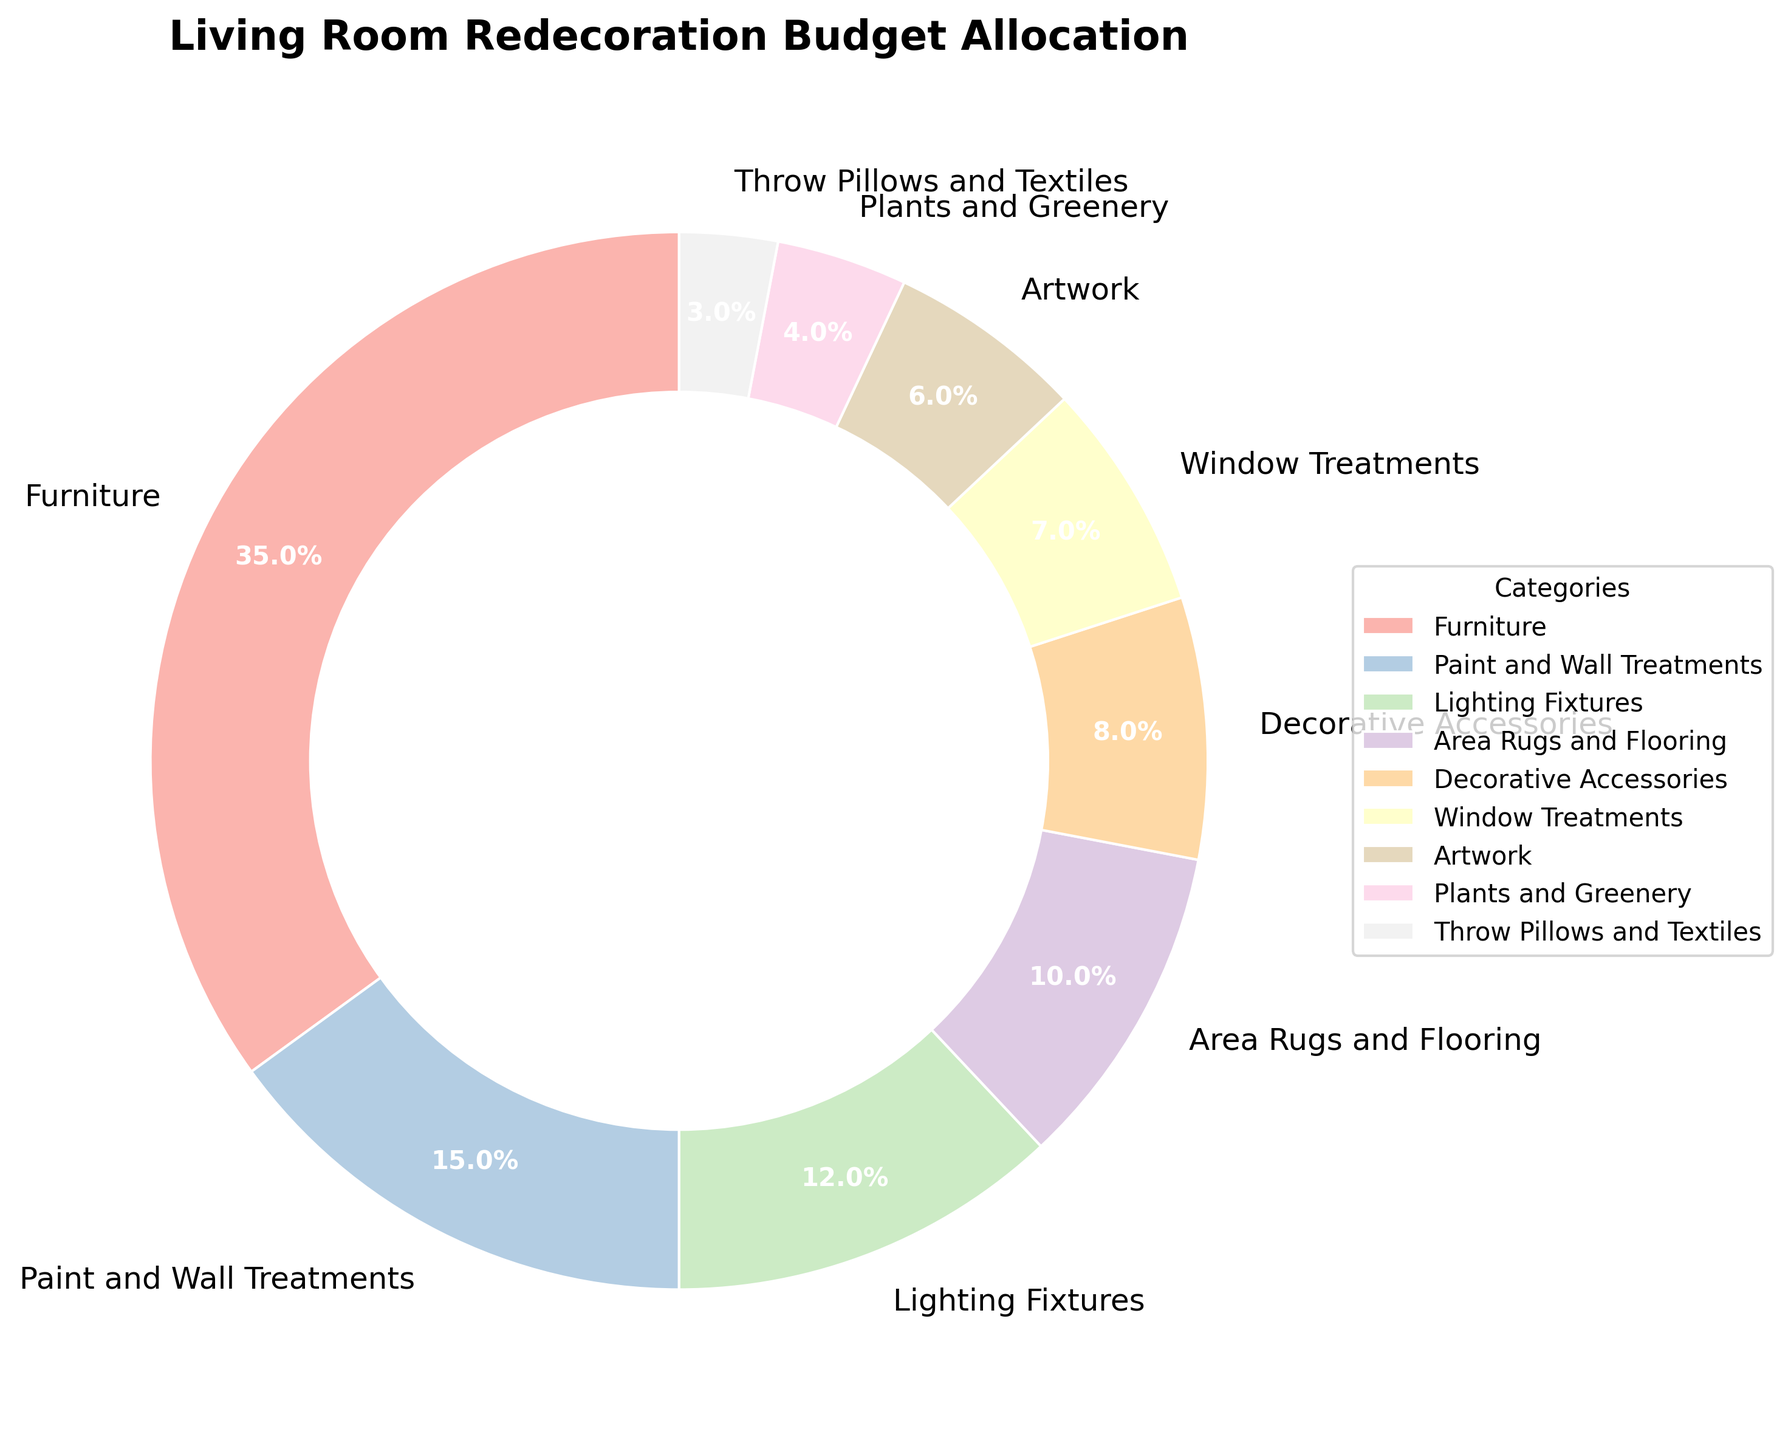What's the largest budget category? By looking at the pie chart, the largest segment corresponds to "Furniture" with a percentage of 35%.
Answer: Furniture Which category has the smallest budget allocation? The smallest segment in the pie chart is for "Throw Pillows and Textiles," which has a 3% allocation.
Answer: Throw Pillows and Textiles What is the combined percentage for Paint and Wall Treatments and Lighting Fixtures? The percentage for Paint and Wall Treatments is 15%, and for Lighting Fixtures, it is 12%. Adding these together: 15% + 12% = 27%.
Answer: 27% Is the budget allocated to Plants and Greenery greater than the budget for Throw Pillows and Textiles? The percentage for Plants and Greenery is 4%, while that for Throw Pillows and Textiles is 3%. Since 4% is greater than 3%, the budget for Plants and Greenery is indeed greater.
Answer: Yes What's the difference in budget percentage between Decorative Accessories and Artwork? Decorative Accessories have an 8% budget allocation, while Artwork has 6%. The difference is calculated as: 8% - 6% = 2%.
Answer: 2% What's the sum of the percentages for Window Treatments, Artwork, and Plants and Greenery? The budget allocations for Window Treatments, Artwork, and Plants and Greenery are 7%, 6%, and 4% respectively. Adding these together: 7% + 6% + 4% = 17%.
Answer: 17% How does the budget for Area Rugs and Flooring compare to the budget for Lighting Fixtures? The pie chart shows that both categories have relatively similar sizes. The allocation for Lighting Fixtures is 12%, and for Area Rugs and Flooring, it is 10%. Since 12% is greater than 10%, the budget for Lighting Fixtures is higher.
Answer: The budget for Lighting Fixtures is higher Which category is represented by approximately 1/3 of the total budget? The pie chart shows that "Furniture" has an allocation of 35%, which is approximately 1/3 of the total budget (since 1/3 is about 33.33%).
Answer: Furniture Are there more categories with a budget allocation above or below 10%? To determine this, list the percentages: Above 10%: Furniture (35%), Paint and Wall Treatments (15%), Lighting Fixtures (12%). Below 10%: Area Rugs and Flooring (10%), Decorative Accessories (8%), Window Treatments (7%), Artwork (6%), Plants and Greenery (4%), Throw Pillows and Textiles (3%). Counting these, we find there are 3 categories above 10% and 6 below 10%.
Answer: Below 10% What's the budget difference between the largest allocation and the smallest allocation in terms of percentage? The largest allocation is for Furniture at 35%, and the smallest for Throw Pillows and Textiles at 3%. The difference is calculated as: 35% - 3% = 32%.
Answer: 32% 